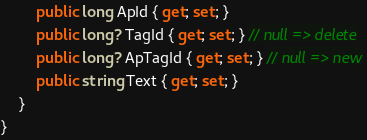Convert code to text. <code><loc_0><loc_0><loc_500><loc_500><_C#_>        public long ApId { get; set; }
        public long? TagId { get; set; } // null => delete
        public long? ApTagId { get; set; } // null => new
        public string Text { get; set; }
    }
}
</code> 